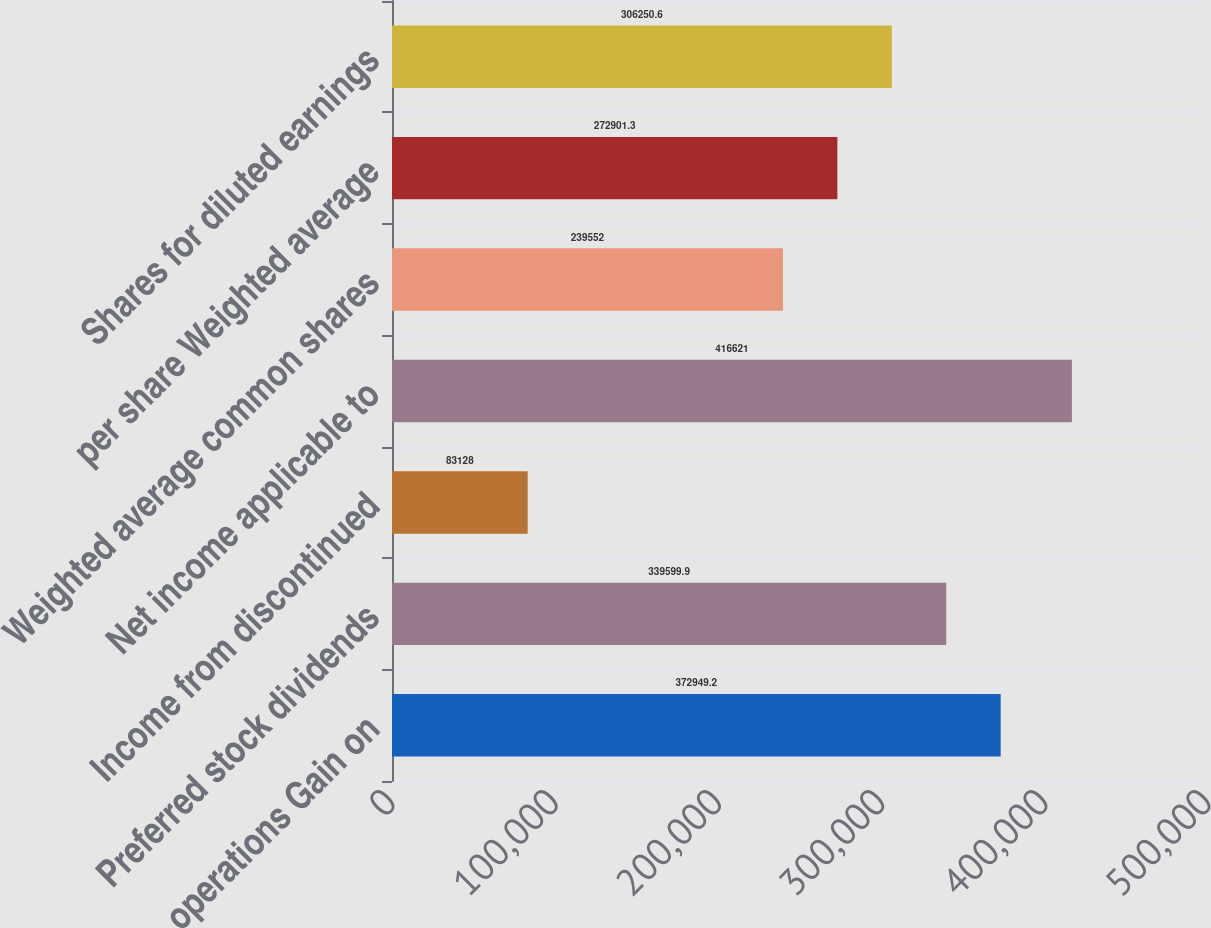Convert chart to OTSL. <chart><loc_0><loc_0><loc_500><loc_500><bar_chart><fcel>operations Gain on<fcel>Preferred stock dividends<fcel>Income from discontinued<fcel>Net income applicable to<fcel>Weighted average common shares<fcel>per share Weighted average<fcel>Shares for diluted earnings<nl><fcel>372949<fcel>339600<fcel>83128<fcel>416621<fcel>239552<fcel>272901<fcel>306251<nl></chart> 